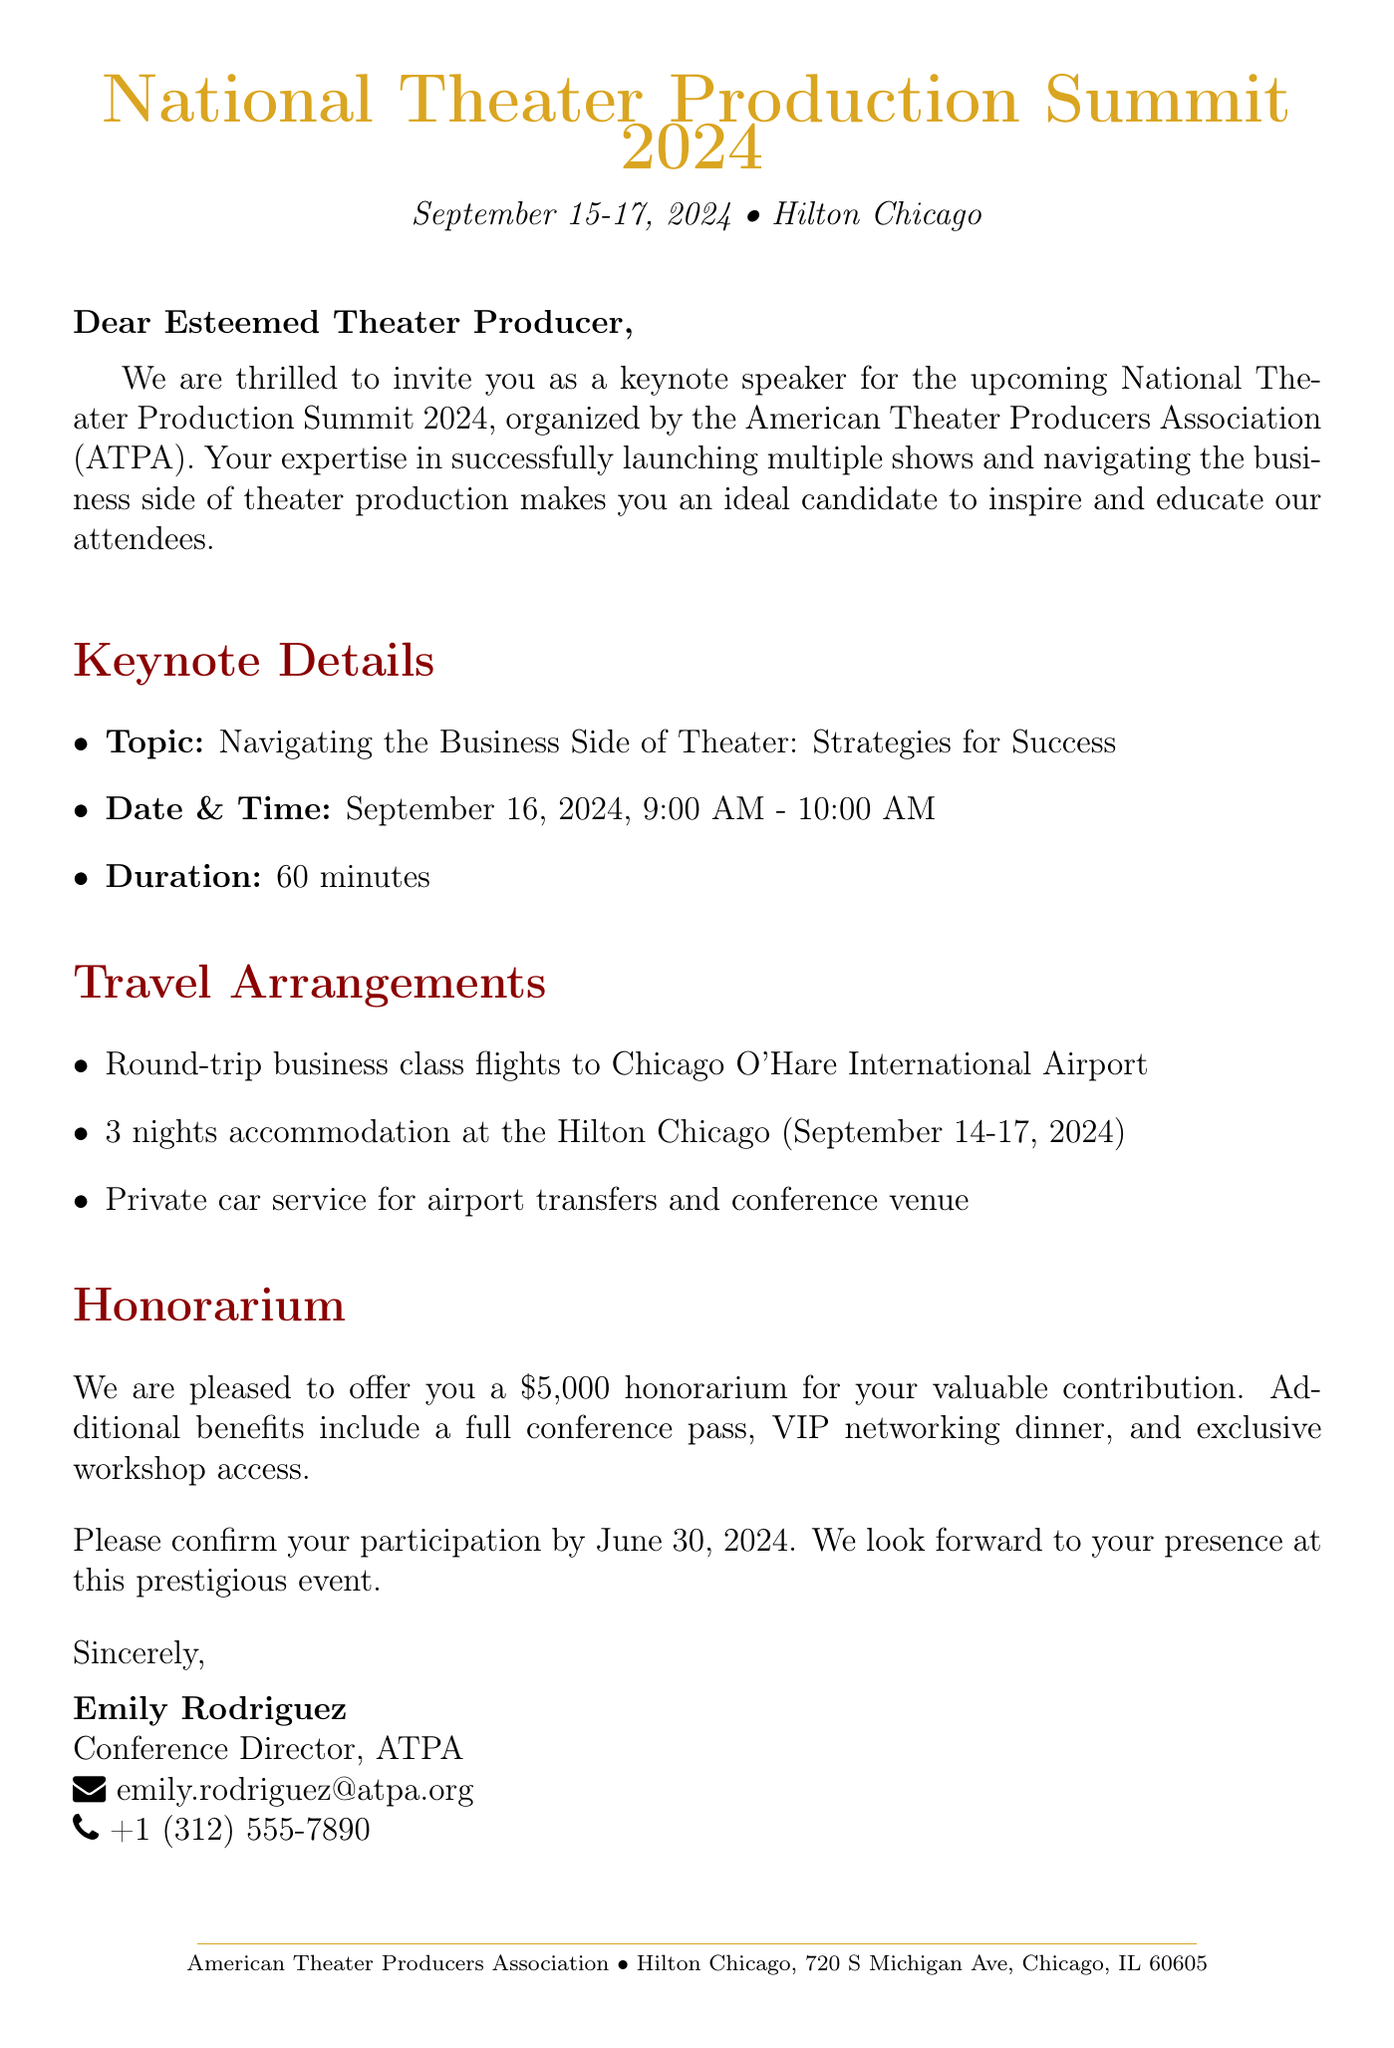What is the name of the conference? The name of the conference mentioned in the document is the National Theater Production Summit 2024.
Answer: National Theater Production Summit 2024 What are the dates of the conference? The dates of the conference, as stated in the document, are September 15-17, 2024.
Answer: September 15-17, 2024 What is the location of the conference? The location provided in the document is the Hilton Chicago, 720 S Michigan Ave, Chicago, IL 60605.
Answer: Hilton Chicago, 720 S Michigan Ave, Chicago, IL 60605 What is the honorarium offered for speaking? The document states that the offered honorarium for speaking is $5,000.
Answer: $5,000 Who is the contact person for the conference? The contact person mentioned in the document is Emily Rodriguez.
Answer: Emily Rodriguez What transportation arrangements are provided? The document specifies private car service for airport transfers and conference venue as part of the transportation arrangements.
Answer: Private car service What time is the keynote speech scheduled? According to the document, the keynote speech is scheduled from 9:00 AM to 10:00 AM.
Answer: 9:00 AM - 10:00 AM What additional benefits are included with the honorarium? The document lists benefits like a full conference pass, VIP networking dinner, and exclusive workshop access.
Answer: Full conference pass, VIP networking dinner, exclusive workshop access When is the participation confirmation deadline? The participation confirmation deadline stated in the document is June 30, 2024.
Answer: June 30, 2024 